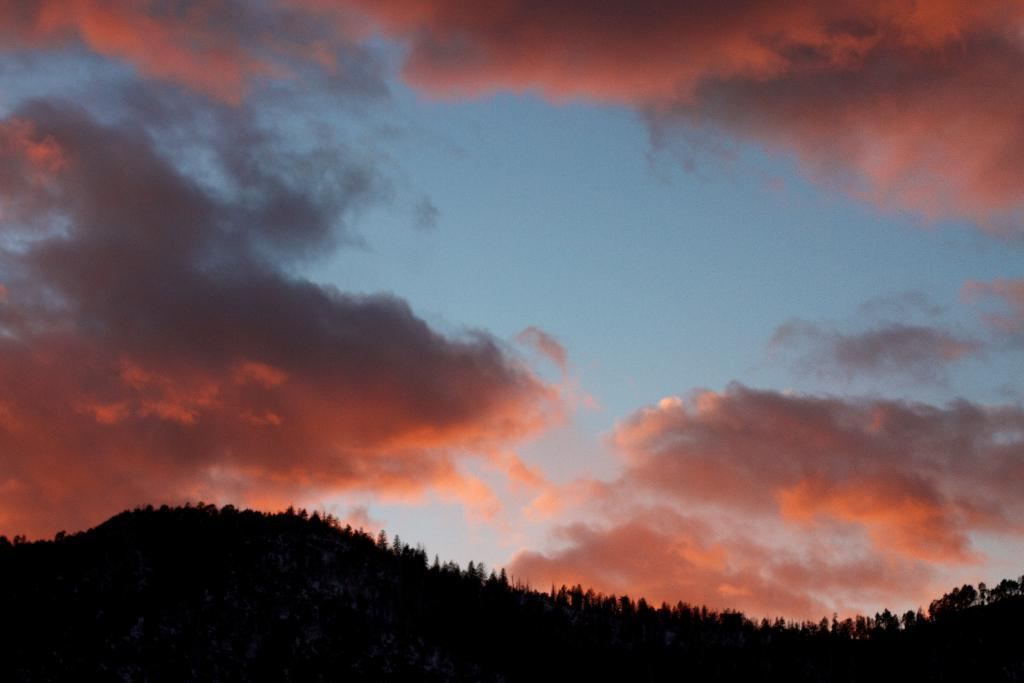What geographical feature is the main subject of the image? There is a mountain in the image. What is covering the mountain? The mountain is covered with trees. What is the condition of the sky in the image? The sky above the mountain has red clouds. What type of base can be seen at the bottom of the mountain in the image? There is no base visible at the bottom of the mountain in the image. How does the achiever feel about climbing the mountain in the image? There is no achiever present in the image, so it cannot be determined how they might feel about climbing the mountain. 